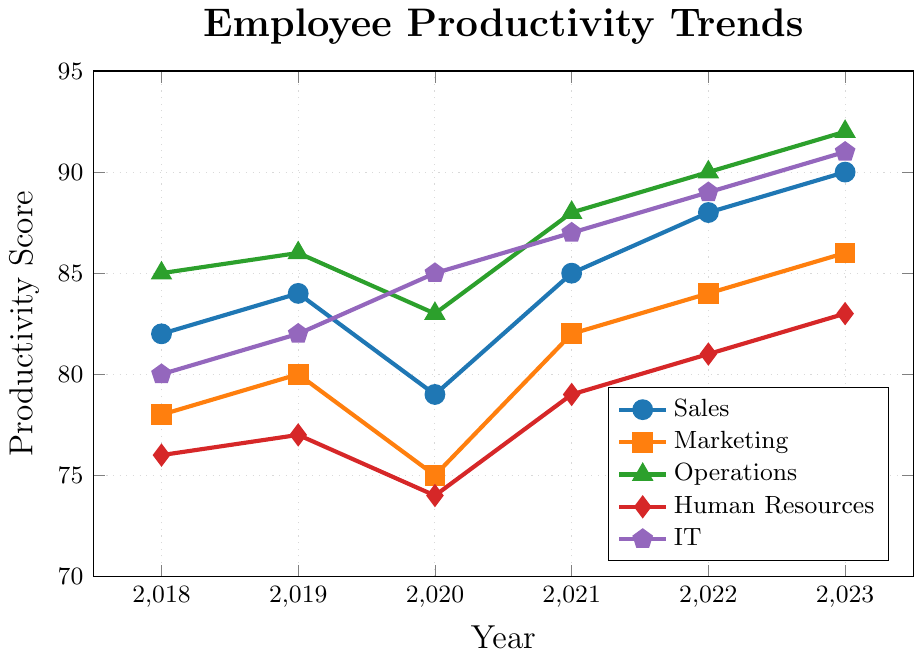What's the overall trend for the Sales department's productivity from 2018 to 2023? By observing the plotted points for Sales over the timeline from 2018 to 2023, we see an overall upward trend. In 2018, the value was 82, and it gradually increased to 90 by 2023.
Answer: Upward trend Which department had the highest productivity score in 2023? By looking at the end of each line representing different departments in 2023, we see Operations at the top with a value of 92.
Answer: Operations Compare the productivity trends of IT and Human Resources from 2018 to 2023. Which one improved more? IT starts at a productivity score of 80 in 2018 and ends at 91 in 2023, an increase of 11 points. Human Resources starts at 76 in 2018 and ends at 83 in 2023, an increase of 7 points. Therefore, IT improved more.
Answer: IT What is the average productivity score of the Marketing department across all years shown? Sum of Marketing scores: 78 + 80 + 75 + 82 + 84 + 86 = 485. There are 6 data points, so the average is 485 / 6 = 80.83.
Answer: 80.83 Which department experienced a decrease in productivity in any of the years? By observing the plotted lines, we can see that in 2020, Sales' productivity dropped from 84 (2019) to 79 (2020), Marketing dropped from 80 (2019) to 75 (2020), and Operations dropped from 86 (2019) to 83 (2020).
Answer: Sales, Marketing, Operations What is the productivity difference between Operations and Sales in 2023? Operations' productivity in 2023 is 92, and Sales' productivity in 2023 is 90. The difference is 92 - 90.
Answer: 2 What is the productivity score for the department represented by the green line in 2022? The green line corresponds to Operations. In the year 2022, the Operations score is 90.
Answer: 90 What year did Sales' productivity match IT's productivity? By observing the plotted points for Sales and IT, we see that in 2019, both departments had a productivity score of 84.
Answer: 2019 Which department shows the most consistent growth from 2018 to 2023? By observing the plotted lines for a consistent positive slope, IT shows consistent growth each year from 2018 (80) to 2023 (91).
Answer: IT 